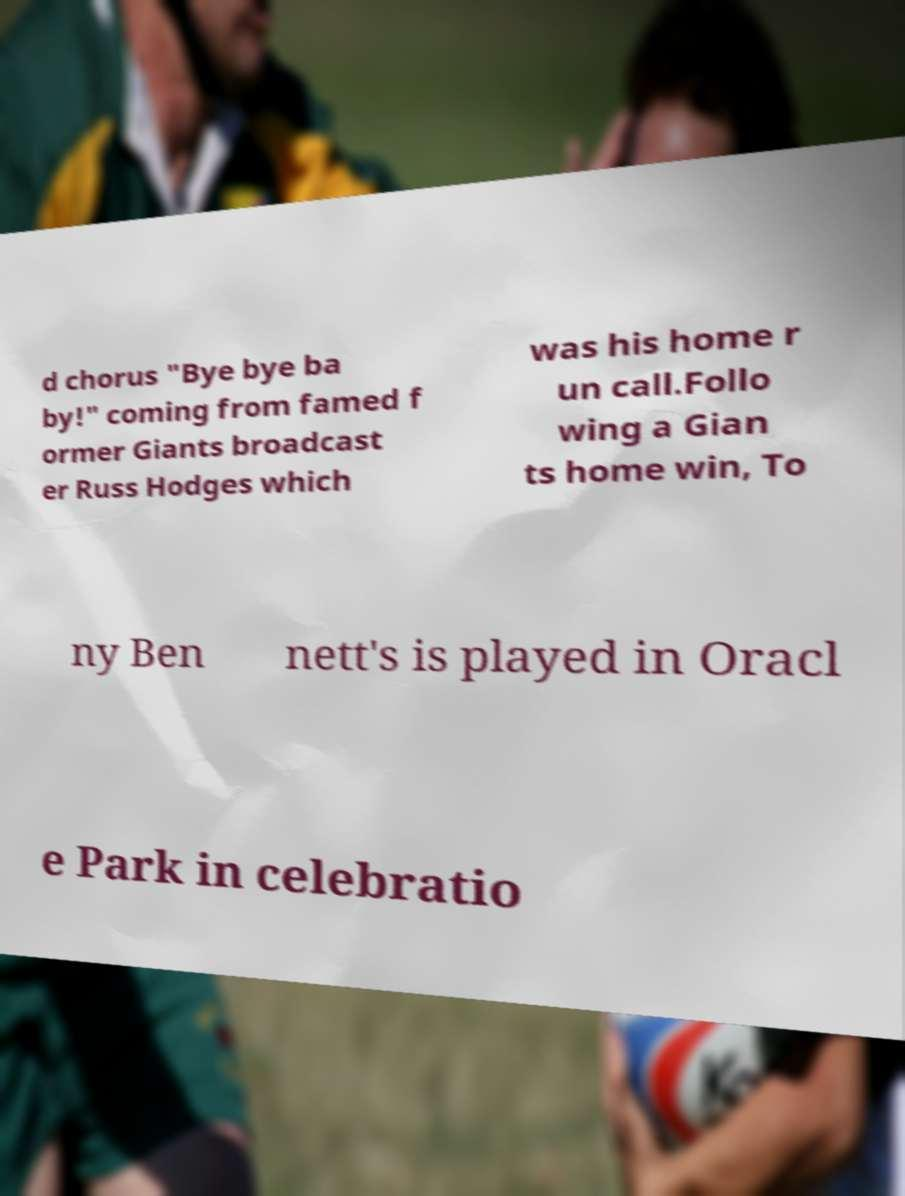Could you assist in decoding the text presented in this image and type it out clearly? d chorus "Bye bye ba by!" coming from famed f ormer Giants broadcast er Russ Hodges which was his home r un call.Follo wing a Gian ts home win, To ny Ben nett's is played in Oracl e Park in celebratio 